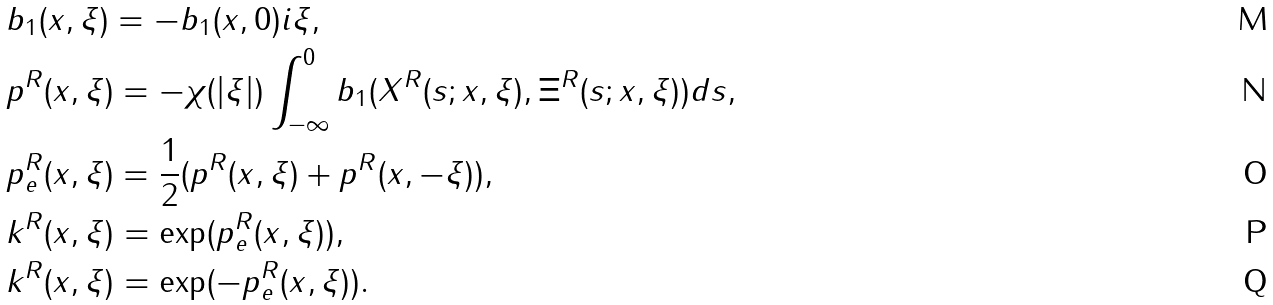Convert formula to latex. <formula><loc_0><loc_0><loc_500><loc_500>& b _ { 1 } ( x , \xi ) = - b _ { 1 } ( x , 0 ) i \xi , \\ & p ^ { R } ( x , \xi ) = - \chi ( | \xi | ) \int _ { - \infty } ^ { 0 } b _ { 1 } ( X ^ { R } ( s ; x , \xi ) , \Xi ^ { R } ( s ; x , \xi ) ) d s , \\ & p _ { e } ^ { R } ( x , \xi ) = \frac { 1 } { 2 } ( p ^ { R } ( x , \xi ) + p ^ { R } ( x , - \xi ) ) , \\ & k ^ { R } ( x , \xi ) = \exp ( p _ { e } ^ { R } ( x , \xi ) ) , \\ & k ^ { R } ( x , \xi ) = \exp ( - p _ { e } ^ { R } ( x , \xi ) ) .</formula> 